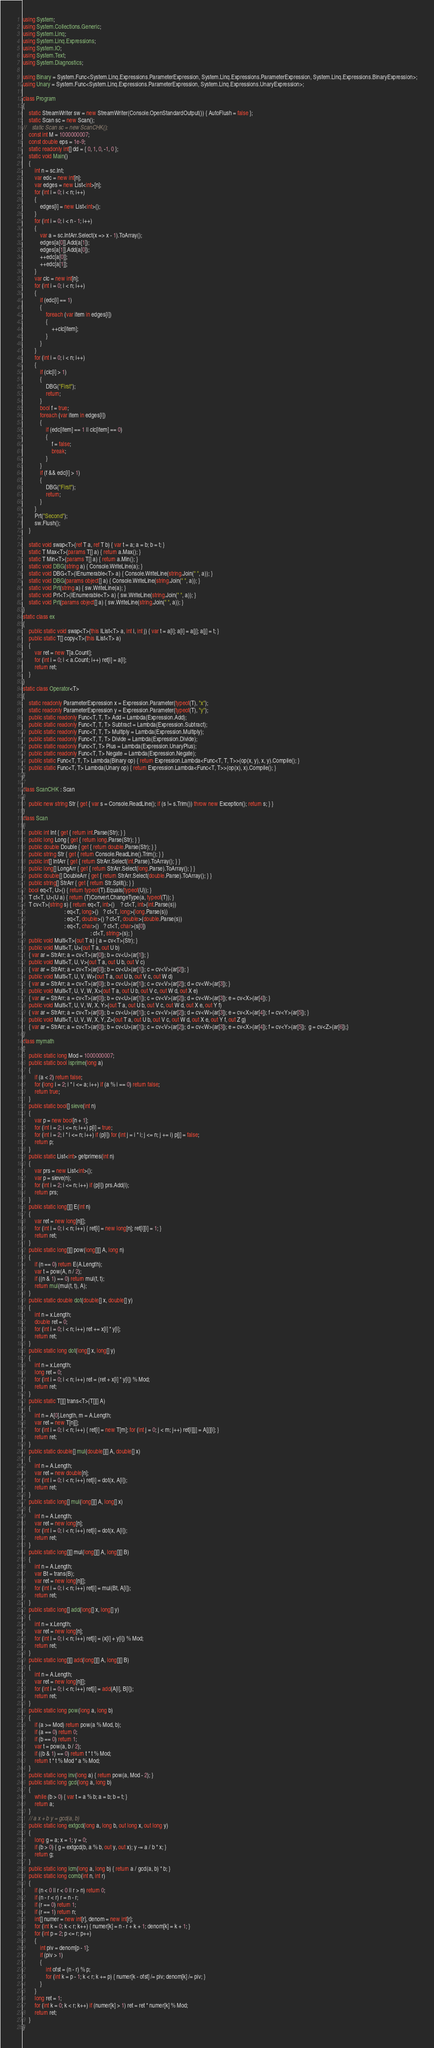<code> <loc_0><loc_0><loc_500><loc_500><_C#_>using System;
using System.Collections.Generic;
using System.Linq;
using System.Linq.Expressions;
using System.IO;
using System.Text;
using System.Diagnostics;

using Binary = System.Func<System.Linq.Expressions.ParameterExpression, System.Linq.Expressions.ParameterExpression, System.Linq.Expressions.BinaryExpression>;
using Unary = System.Func<System.Linq.Expressions.ParameterExpression, System.Linq.Expressions.UnaryExpression>;

class Program
{
    static StreamWriter sw = new StreamWriter(Console.OpenStandardOutput()) { AutoFlush = false };
    static Scan sc = new Scan();
//    static Scan sc = new ScanCHK();
    const int M = 1000000007;
    const double eps = 1e-9;
    static readonly int[] dd = { 0, 1, 0, -1, 0 };
    static void Main()
    {
        int n = sc.Int;
        var edc = new int[n];
        var edges = new List<int>[n];
        for (int i = 0; i < n; i++)
        {
            edges[i] = new List<int>();
        }
        for (int i = 0; i < n - 1; i++)
        {
            var a = sc.IntArr.Select(x => x - 1).ToArray();
            edges[a[0]].Add(a[1]);
            edges[a[1]].Add(a[0]);
            ++edc[a[0]];
            ++edc[a[1]];
        }
        var clc = new int[n];
        for (int i = 0; i < n; i++)
        {
            if (edc[i] == 1)
            {
                foreach (var item in edges[i])
                {
                    ++clc[item];
                }
            }
        }
        for (int i = 0; i < n; i++)
        {
            if (clc[i] > 1)
            {
                DBG("First");
                return;
            }
            bool f = true;
            foreach (var item in edges[i])
            {
                if (edc[item] == 1 || clc[item] == 0)
                {
                    f = false;
                    break;
                }
            }
            if (f && edc[i] > 1)
            {
                DBG("First");
                return;
            }
        }
        Prt("Second");
        sw.Flush();
    }

    static void swap<T>(ref T a, ref T b) { var t = a; a = b; b = t; }
    static T Max<T>(params T[] a) { return a.Max(); }
    static T Min<T>(params T[] a) { return a.Min(); }
    static void DBG(string a) { Console.WriteLine(a); }
    static void DBG<T>(IEnumerable<T> a) { Console.WriteLine(string.Join(" ", a)); }
    static void DBG(params object[] a) { Console.WriteLine(string.Join(" ", a)); }
    static void Prt(string a) { sw.WriteLine(a); }
    static void Prt<T>(IEnumerable<T> a) { sw.WriteLine(string.Join(" ", a)); }
    static void Prt(params object[] a) { sw.WriteLine(string.Join(" ", a)); }
}
static class ex
{
    public static void swap<T>(this IList<T> a, int i, int j) { var t = a[i]; a[i] = a[j]; a[j] = t; }
    public static T[] copy<T>(this IList<T> a)
    {
        var ret = new T[a.Count];
        for (int i = 0; i < a.Count; i++) ret[i] = a[i];
        return ret;
    }
}
static class Operator<T>
{
    static readonly ParameterExpression x = Expression.Parameter(typeof(T), "x");
    static readonly ParameterExpression y = Expression.Parameter(typeof(T), "y");
    public static readonly Func<T, T, T> Add = Lambda(Expression.Add);
    public static readonly Func<T, T, T> Subtract = Lambda(Expression.Subtract);
    public static readonly Func<T, T, T> Multiply = Lambda(Expression.Multiply);
    public static readonly Func<T, T, T> Divide = Lambda(Expression.Divide);
    public static readonly Func<T, T> Plus = Lambda(Expression.UnaryPlus);
    public static readonly Func<T, T> Negate = Lambda(Expression.Negate);
    public static Func<T, T, T> Lambda(Binary op) { return Expression.Lambda<Func<T, T, T>>(op(x, y), x, y).Compile(); }
    public static Func<T, T> Lambda(Unary op) { return Expression.Lambda<Func<T, T>>(op(x), x).Compile(); }
}

class ScanCHK : Scan
{
    public new string Str { get { var s = Console.ReadLine(); if (s != s.Trim()) throw new Exception(); return s; } }
}
class Scan
{
    public int Int { get { return int.Parse(Str); } }
    public long Long { get { return long.Parse(Str); } }
    public double Double { get { return double.Parse(Str); } }
    public string Str { get { return Console.ReadLine().Trim(); } }
    public int[] IntArr { get { return StrArr.Select(int.Parse).ToArray(); } }
    public long[] LongArr { get { return StrArr.Select(long.Parse).ToArray(); } }
    public double[] DoubleArr { get { return StrArr.Select(double.Parse).ToArray(); } }
    public string[] StrArr { get { return Str.Split(); } }
    bool eq<T, U>() { return typeof(T).Equals(typeof(U)); }
    T ct<T, U>(U a) { return (T)Convert.ChangeType(a, typeof(T)); }
    T cv<T>(string s) { return eq<T, int>()    ? ct<T, int>(int.Parse(s))
                             : eq<T, long>()   ? ct<T, long>(long.Parse(s))
                             : eq<T, double>() ? ct<T, double>(double.Parse(s))
                             : eq<T, char>()   ? ct<T, char>(s[0])
                                               : ct<T, string>(s); }
    public void Multi<T>(out T a) { a = cv<T>(Str); }
    public void Multi<T, U>(out T a, out U b)
    { var ar = StrArr; a = cv<T>(ar[0]); b = cv<U>(ar[1]); }
    public void Multi<T, U, V>(out T a, out U b, out V c)
    { var ar = StrArr; a = cv<T>(ar[0]); b = cv<U>(ar[1]); c = cv<V>(ar[2]); }
    public void Multi<T, U, V, W>(out T a, out U b, out V c, out W d)
    { var ar = StrArr; a = cv<T>(ar[0]); b = cv<U>(ar[1]); c = cv<V>(ar[2]); d = cv<W>(ar[3]); }
    public void Multi<T, U, V, W, X>(out T a, out U b, out V c, out W d, out X e)
    { var ar = StrArr; a = cv<T>(ar[0]); b = cv<U>(ar[1]); c = cv<V>(ar[2]); d = cv<W>(ar[3]); e = cv<X>(ar[4]); }
    public void Multi<T, U, V, W, X, Y>(out T a, out U b, out V c, out W d, out X e, out Y f)
    { var ar = StrArr; a = cv<T>(ar[0]); b = cv<U>(ar[1]); c = cv<V>(ar[2]); d = cv<W>(ar[3]); e = cv<X>(ar[4]); f = cv<Y>(ar[5]); }
    public void Multi<T, U, V, W, X, Y, Z>(out T a, out U b, out V c, out W d, out X e, out Y f, out Z g)
    { var ar = StrArr; a = cv<T>(ar[0]); b = cv<U>(ar[1]); c = cv<V>(ar[2]); d = cv<W>(ar[3]); e = cv<X>(ar[4]); f = cv<Y>(ar[5]);  g = cv<Z>(ar[6]);}
}
class mymath
{
    public static long Mod = 1000000007;
    public static bool isprime(long a)
    {
        if (a < 2) return false;
        for (long i = 2; i * i <= a; i++) if (a % i == 0) return false;
        return true;
    }
    public static bool[] sieve(int n)
    {
        var p = new bool[n + 1];
        for (int i = 2; i <= n; i++) p[i] = true;
        for (int i = 2; i * i <= n; i++) if (p[i]) for (int j = i * i; j <= n; j += i) p[j] = false;
        return p;
    }
    public static List<int> getprimes(int n)
    {
        var prs = new List<int>();
        var p = sieve(n);
        for (int i = 2; i <= n; i++) if (p[i]) prs.Add(i);
        return prs;
    }
    public static long[][] E(int n)
    {
        var ret = new long[n][];
        for (int i = 0; i < n; i++) { ret[i] = new long[n]; ret[i][i] = 1; }
        return ret;
    }
    public static long[][] pow(long[][] A, long n)
    {
        if (n == 0) return E(A.Length);
        var t = pow(A, n / 2);
        if ((n & 1) == 0) return mul(t, t);
        return mul(mul(t, t), A);
    }
    public static double dot(double[] x, double[] y)
    {
        int n = x.Length;
        double ret = 0;
        for (int i = 0; i < n; i++) ret += x[i] * y[i];
        return ret;
    }
    public static long dot(long[] x, long[] y)
    {
        int n = x.Length;
        long ret = 0;
        for (int i = 0; i < n; i++) ret = (ret + x[i] * y[i]) % Mod;
        return ret;
    }
    public static T[][] trans<T>(T[][] A)
    {
        int n = A[0].Length, m = A.Length;
        var ret = new T[n][];
        for (int i = 0; i < n; i++) { ret[i] = new T[m]; for (int j = 0; j < m; j++) ret[i][j] = A[j][i]; }
        return ret;
    }
    public static double[] mul(double[][] A, double[] x)
    {
        int n = A.Length;
        var ret = new double[n];
        for (int i = 0; i < n; i++) ret[i] = dot(x, A[i]);
        return ret;
    }
    public static long[] mul(long[][] A, long[] x)
    {
        int n = A.Length;
        var ret = new long[n];
        for (int i = 0; i < n; i++) ret[i] = dot(x, A[i]);
        return ret;
    }
    public static long[][] mul(long[][] A, long[][] B)
    {
        int n = A.Length;
        var Bt = trans(B);
        var ret = new long[n][];
        for (int i = 0; i < n; i++) ret[i] = mul(Bt, A[i]);
        return ret;
    }
    public static long[] add(long[] x, long[] y)
    {
        int n = x.Length;
        var ret = new long[n];
        for (int i = 0; i < n; i++) ret[i] = (x[i] + y[i]) % Mod;
        return ret;
    }
    public static long[][] add(long[][] A, long[][] B)
    {
        int n = A.Length;
        var ret = new long[n][];
        for (int i = 0; i < n; i++) ret[i] = add(A[i], B[i]);
        return ret;
    }
    public static long pow(long a, long b)
    {
        if (a >= Mod) return pow(a % Mod, b);
        if (a == 0) return 0;
        if (b == 0) return 1;
        var t = pow(a, b / 2);
        if ((b & 1) == 0) return t * t % Mod;
        return t * t % Mod * a % Mod;
    }
    public static long inv(long a) { return pow(a, Mod - 2); }
    public static long gcd(long a, long b)
    {
        while (b > 0) { var t = a % b; a = b; b = t; }
        return a;
    }
    // a x + b y = gcd(a, b)
    public static long extgcd(long a, long b, out long x, out long y)
    {
        long g = a; x = 1; y = 0;
        if (b > 0) { g = extgcd(b, a % b, out y, out x); y -= a / b * x; }
        return g;
    }
    public static long lcm(long a, long b) { return a / gcd(a, b) * b; }
    public static long comb(int n, int r)
    {
        if (n < 0 || r < 0 || r > n) return 0;
        if (n - r < r) r = n - r;
        if (r == 0) return 1;
        if (r == 1) return n;
        int[] numer = new int[r], denom = new int[r];
        for (int k = 0; k < r; k++) { numer[k] = n - r + k + 1; denom[k] = k + 1; }
        for (int p = 2; p <= r; p++)
        {
            int piv = denom[p - 1];
            if (piv > 1)
            {
                int ofst = (n - r) % p;
                for (int k = p - 1; k < r; k += p) { numer[k - ofst] /= piv; denom[k] /= piv; }
            }
        }
        long ret = 1;
        for (int k = 0; k < r; k++) if (numer[k] > 1) ret = ret * numer[k] % Mod;
        return ret;
    }
}
</code> 